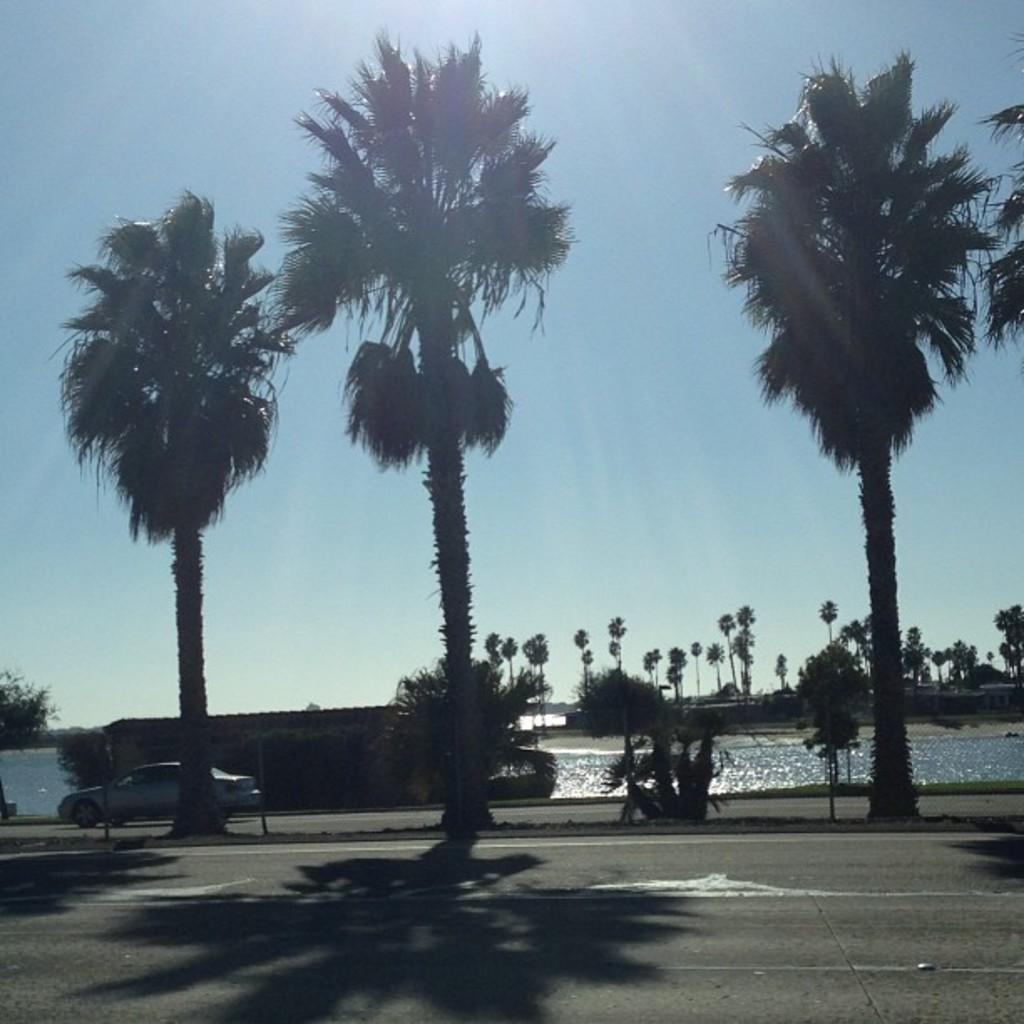What is the main subject of the image? The main subject of the image is a car on the road. What can be seen in the center of the image? There is water in the center of the image. What is located on the side of the road in the image? There is a wall in the image. What type of natural scenery is visible in the background of the image? There are trees in the background of the image. What part of the natural environment is visible in the background of the image? The sky is visible in the background of the image. What type of love is being expressed by the secretary in the image? There is no secretary present in the image, so it is not possible to determine what type of love might be expressed. 